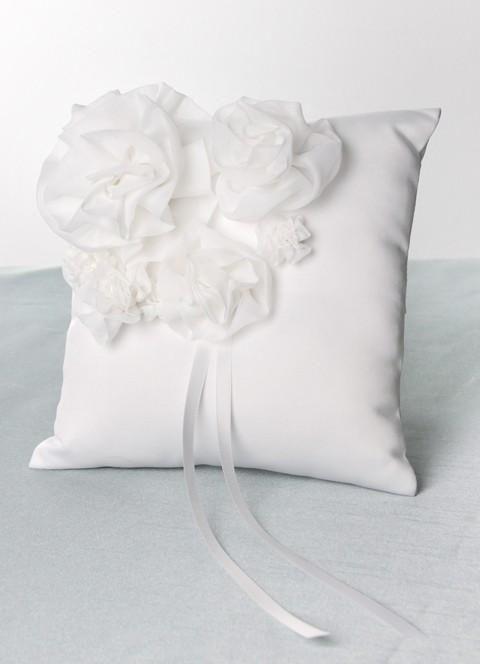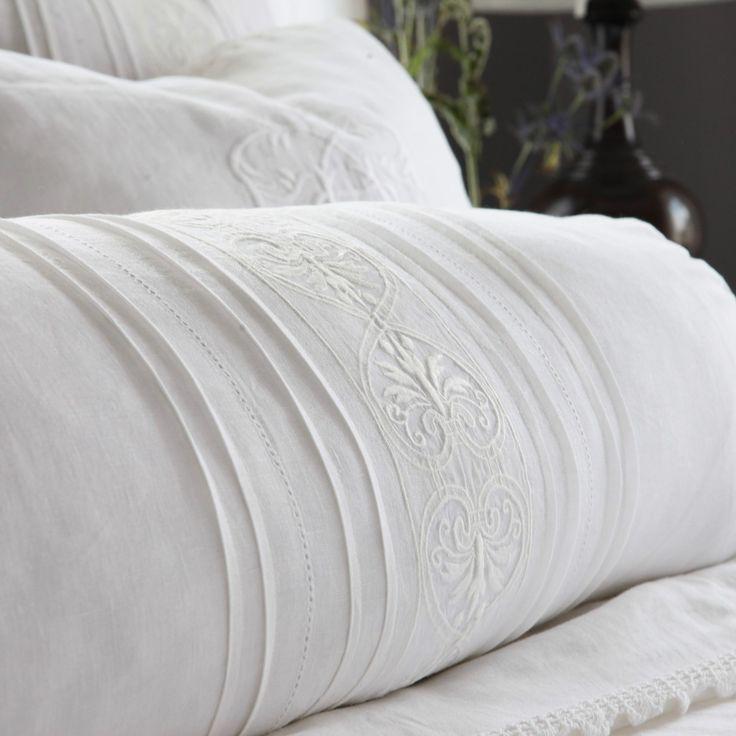The first image is the image on the left, the second image is the image on the right. Given the left and right images, does the statement "There is something pink on a bed." hold true? Answer yes or no. No. 